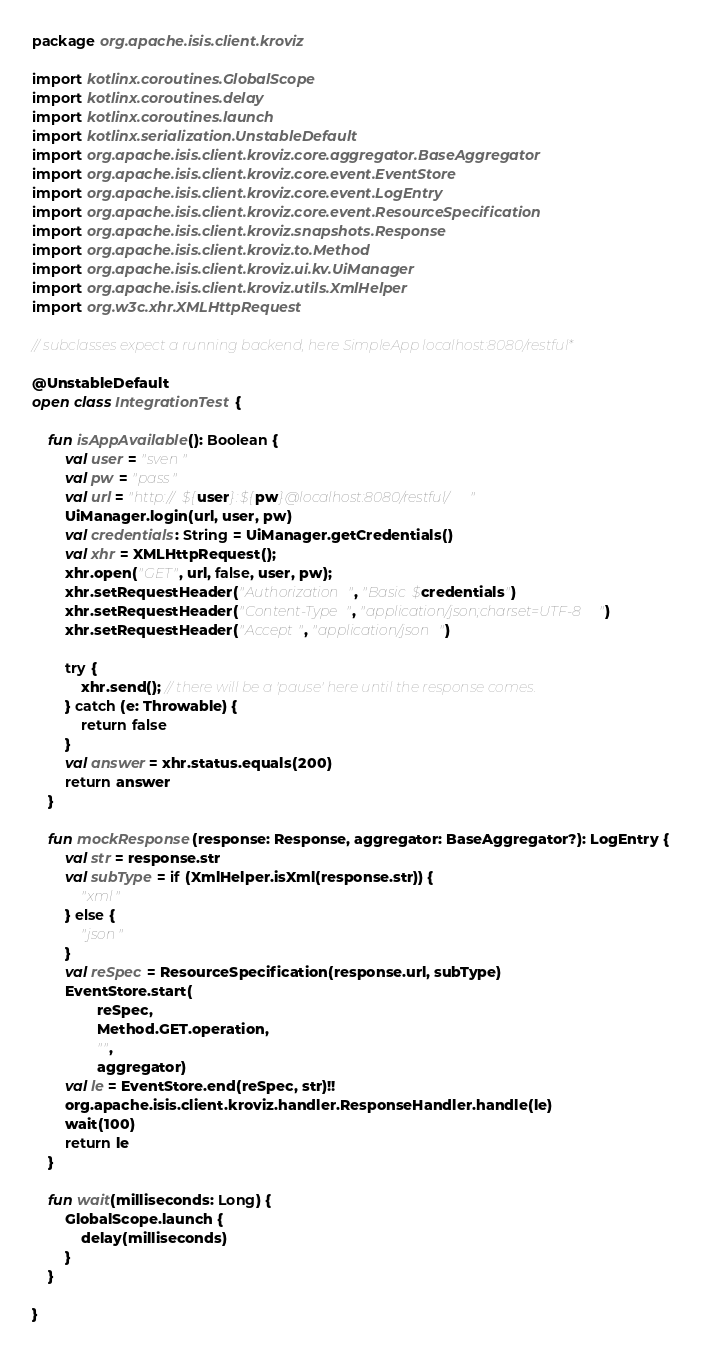<code> <loc_0><loc_0><loc_500><loc_500><_Kotlin_>package org.apache.isis.client.kroviz

import kotlinx.coroutines.GlobalScope
import kotlinx.coroutines.delay
import kotlinx.coroutines.launch
import kotlinx.serialization.UnstableDefault
import org.apache.isis.client.kroviz.core.aggregator.BaseAggregator
import org.apache.isis.client.kroviz.core.event.EventStore
import org.apache.isis.client.kroviz.core.event.LogEntry
import org.apache.isis.client.kroviz.core.event.ResourceSpecification
import org.apache.isis.client.kroviz.snapshots.Response
import org.apache.isis.client.kroviz.to.Method
import org.apache.isis.client.kroviz.ui.kv.UiManager
import org.apache.isis.client.kroviz.utils.XmlHelper
import org.w3c.xhr.XMLHttpRequest

// subclasses expect a running backend, here SimpleApp localhost:8080/restful*

@UnstableDefault
open class IntegrationTest {

    fun isAppAvailable(): Boolean {
        val user = "sven"
        val pw = "pass"
        val url = "http://${user}:${pw}@localhost:8080/restful/"
        UiManager.login(url, user, pw)
        val credentials: String = UiManager.getCredentials()
        val xhr = XMLHttpRequest();
        xhr.open("GET", url, false, user, pw);
        xhr.setRequestHeader("Authorization", "Basic $credentials")
        xhr.setRequestHeader("Content-Type", "application/json;charset=UTF-8")
        xhr.setRequestHeader("Accept", "application/json")

        try {
            xhr.send(); // there will be a 'pause' here until the response comes.
        } catch (e: Throwable) {
            return false
        }
        val answer = xhr.status.equals(200)
        return answer
    }

    fun mockResponse(response: Response, aggregator: BaseAggregator?): LogEntry {
        val str = response.str
        val subType = if (XmlHelper.isXml(response.str)) {
            "xml"
        } else {
            "json"
        }
        val reSpec = ResourceSpecification(response.url, subType)
        EventStore.start(
                reSpec,
                Method.GET.operation,
                "",
                aggregator)
        val le = EventStore.end(reSpec, str)!!
        org.apache.isis.client.kroviz.handler.ResponseHandler.handle(le)
        wait(100)
        return le
    }

    fun wait(milliseconds: Long) {
        GlobalScope.launch {
            delay(milliseconds)
        }
    }

}
</code> 